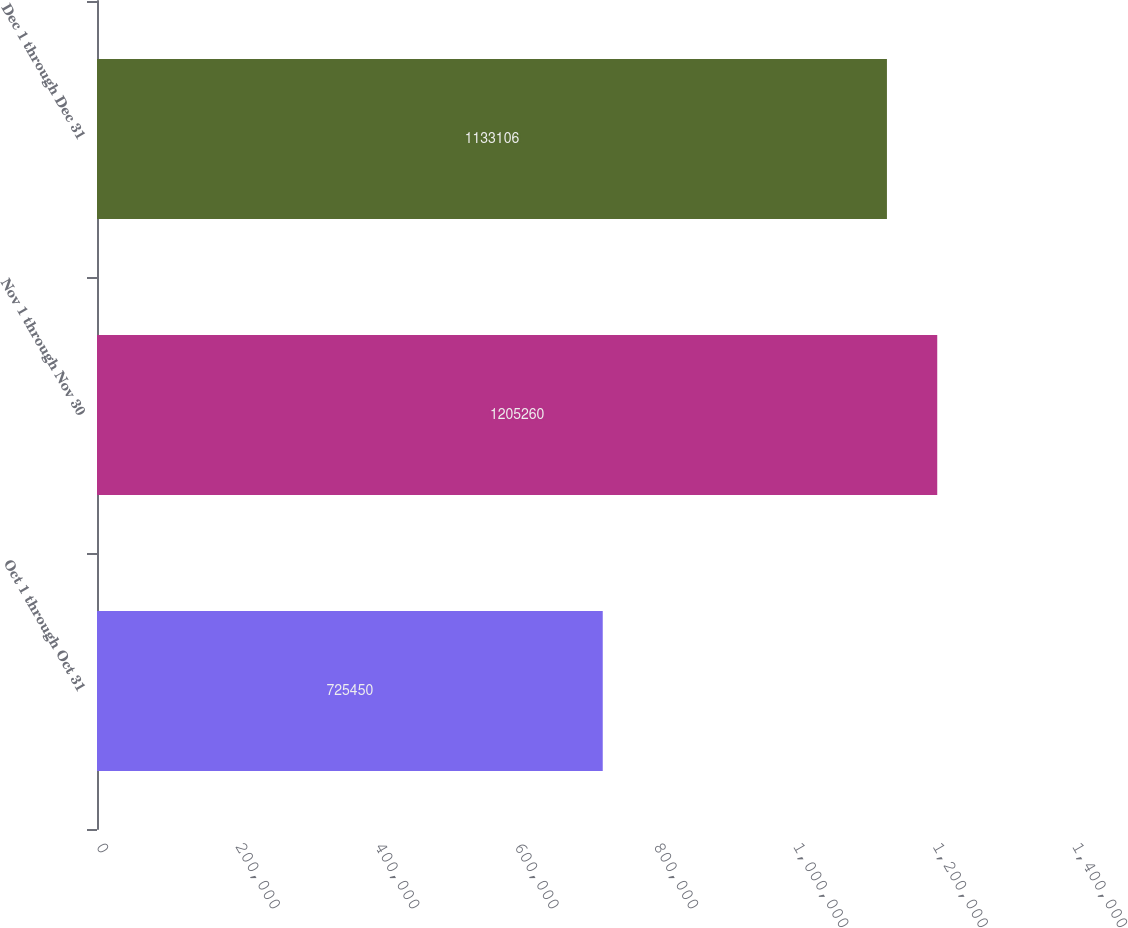Convert chart. <chart><loc_0><loc_0><loc_500><loc_500><bar_chart><fcel>Oct 1 through Oct 31<fcel>Nov 1 through Nov 30<fcel>Dec 1 through Dec 31<nl><fcel>725450<fcel>1.20526e+06<fcel>1.13311e+06<nl></chart> 